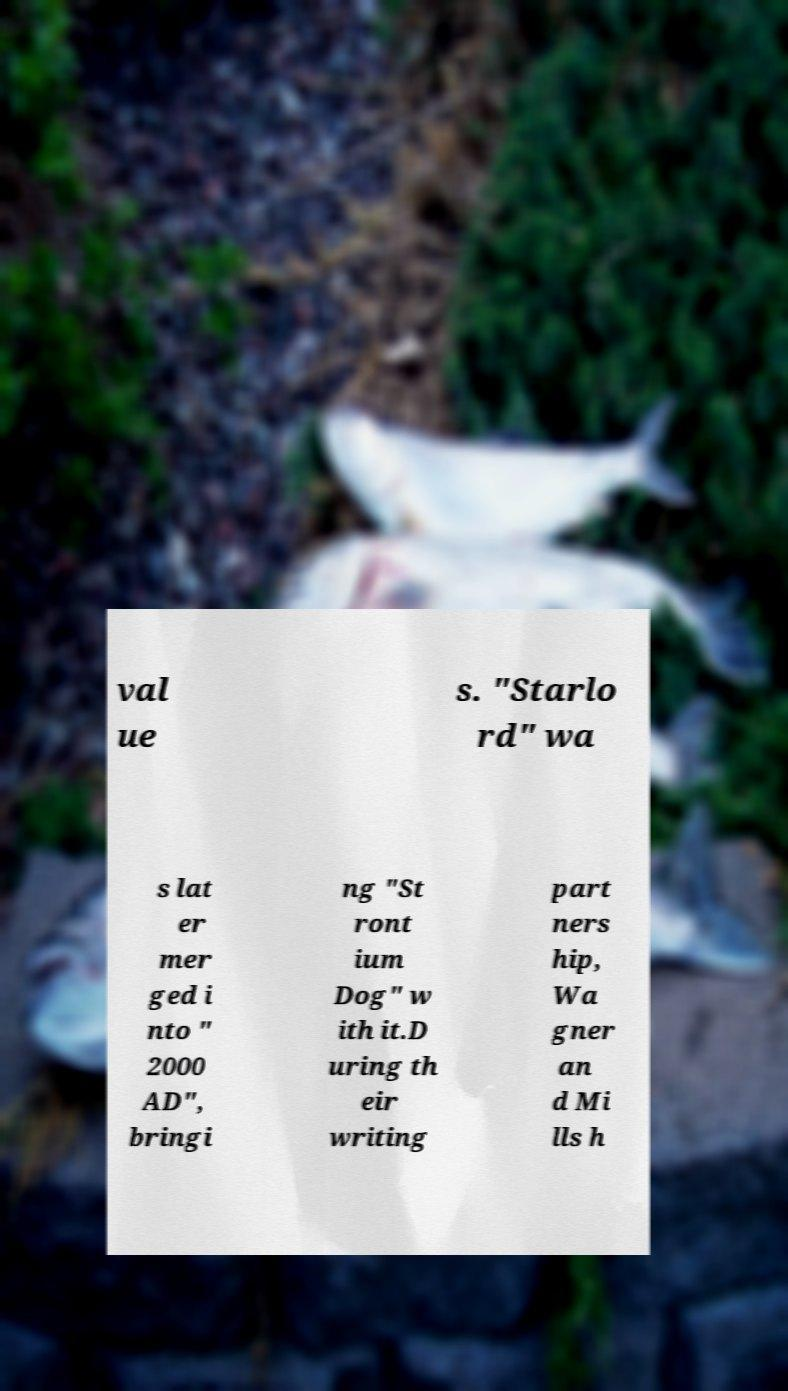There's text embedded in this image that I need extracted. Can you transcribe it verbatim? val ue s. "Starlo rd" wa s lat er mer ged i nto " 2000 AD", bringi ng "St ront ium Dog" w ith it.D uring th eir writing part ners hip, Wa gner an d Mi lls h 